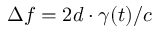Convert formula to latex. <formula><loc_0><loc_0><loc_500><loc_500>\Delta f = 2 d \cdot \gamma ( t ) / c</formula> 